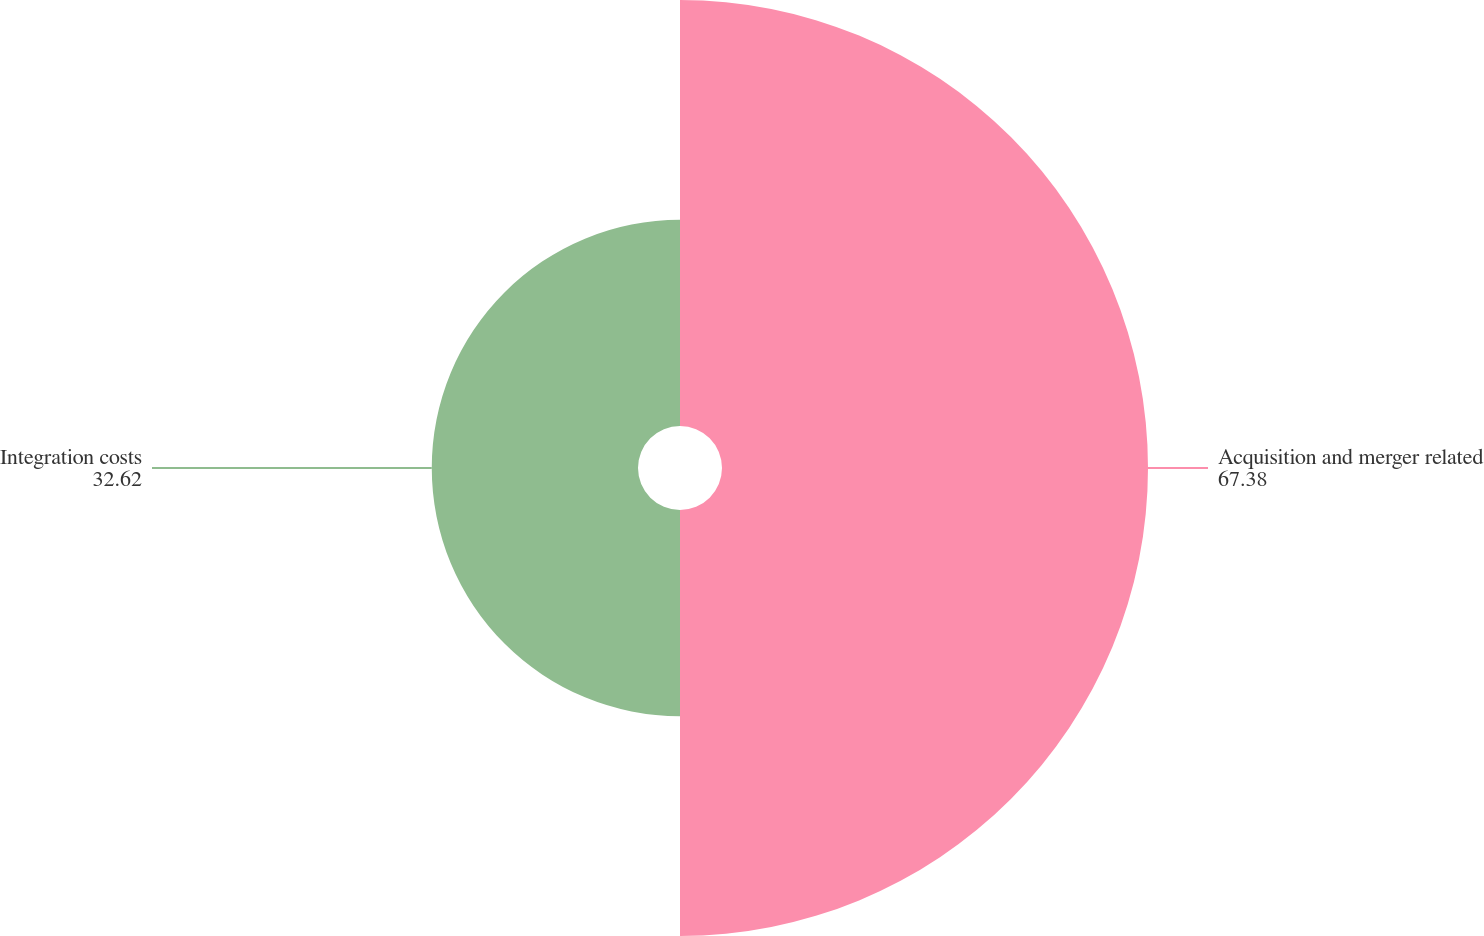Convert chart to OTSL. <chart><loc_0><loc_0><loc_500><loc_500><pie_chart><fcel>Acquisition and merger related<fcel>Integration costs<nl><fcel>67.38%<fcel>32.62%<nl></chart> 